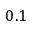Convert formula to latex. <formula><loc_0><loc_0><loc_500><loc_500>0 . 1</formula> 